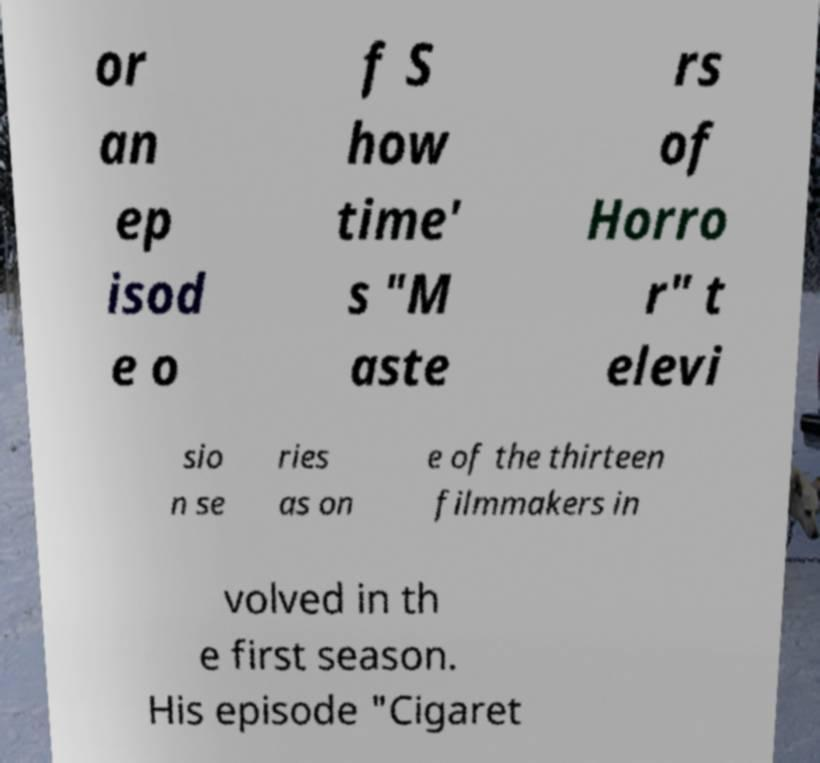I need the written content from this picture converted into text. Can you do that? or an ep isod e o f S how time' s "M aste rs of Horro r" t elevi sio n se ries as on e of the thirteen filmmakers in volved in th e first season. His episode "Cigaret 